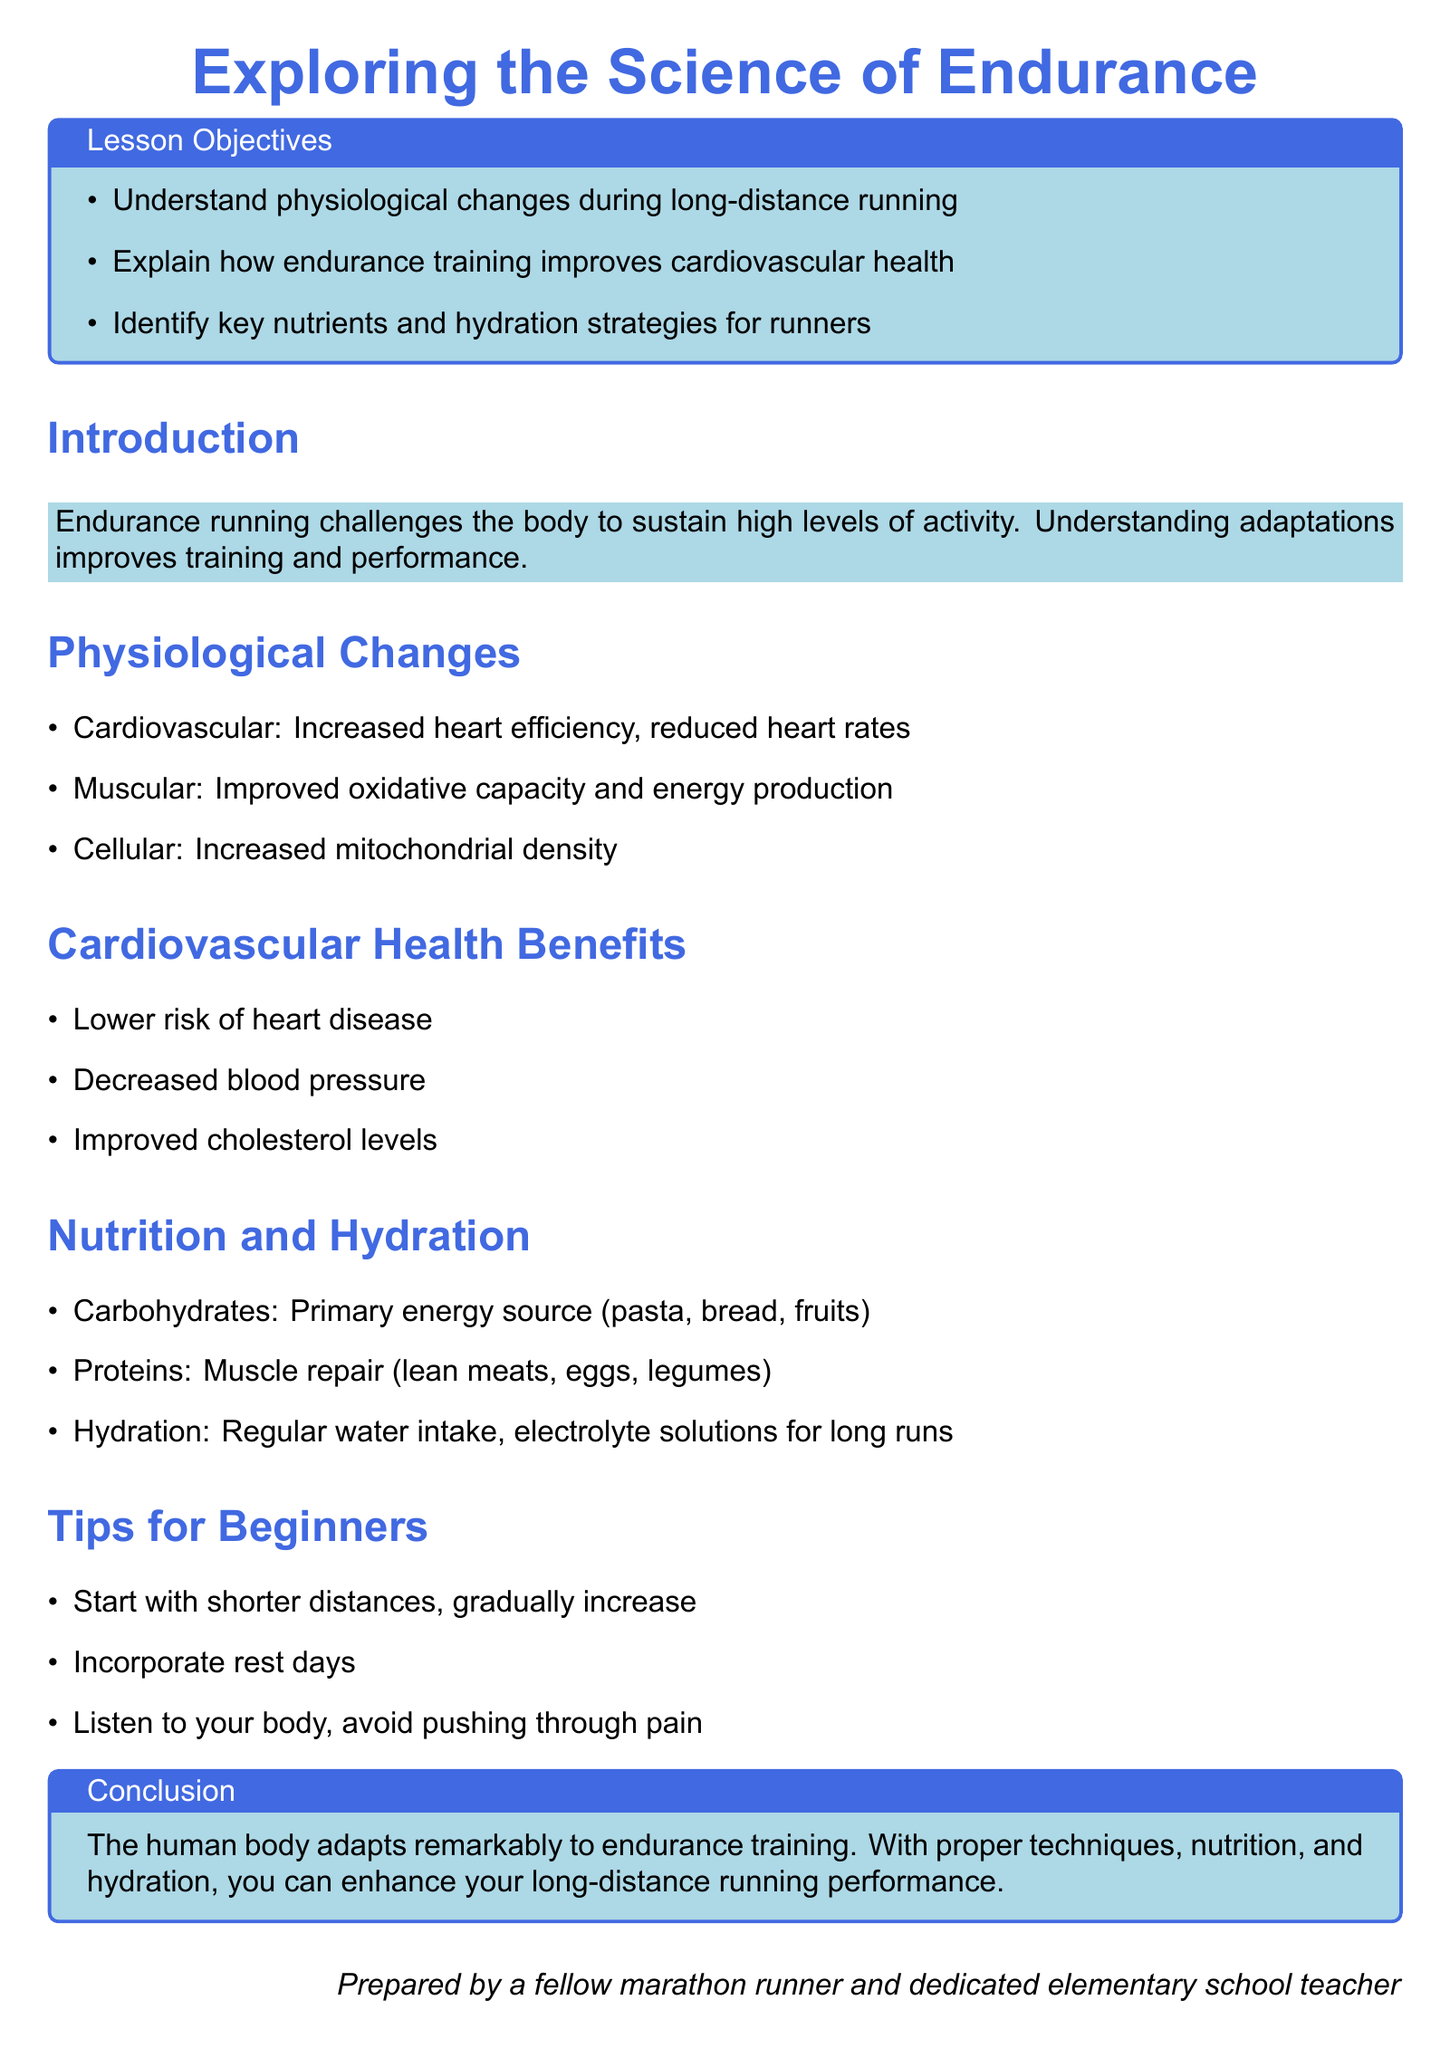what is the main topic of the lesson plan? The main topic is exploring the adaptations of the human body to endurance running.
Answer: Exploring the Science of Endurance how many lesson objectives are listed? The document lists three lesson objectives.
Answer: 3 what is the primary energy source for endurance runners? The primary energy source is listed as carbohydrates.
Answer: Carbohydrates which nutrient is mentioned for muscle repair? The nutrient mentioned for muscle repair is proteins.
Answer: Proteins what is one cardiovascular health benefit of endurance running? One benefit listed is a lower risk of heart disease.
Answer: Lower risk of heart disease what is the recommended action for beginners regarding distances? Beginners are advised to start with shorter distances.
Answer: Start with shorter distances how can hydration be maintained during long runs? Regular water intake and electrolyte solutions are suggested strategies.
Answer: Regular water intake, electrolyte solutions what physiological change involves increased heart efficiency? The physiological change related to increased heart efficiency is cardiovascular adaptation.
Answer: Cardiovascular how should runners approach listening to their body? Runners should avoid pushing through pain.
Answer: Avoid pushing through pain 